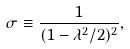Convert formula to latex. <formula><loc_0><loc_0><loc_500><loc_500>\sigma \equiv \frac { 1 } { ( 1 - \lambda ^ { 2 } / 2 ) ^ { 2 } } ,</formula> 